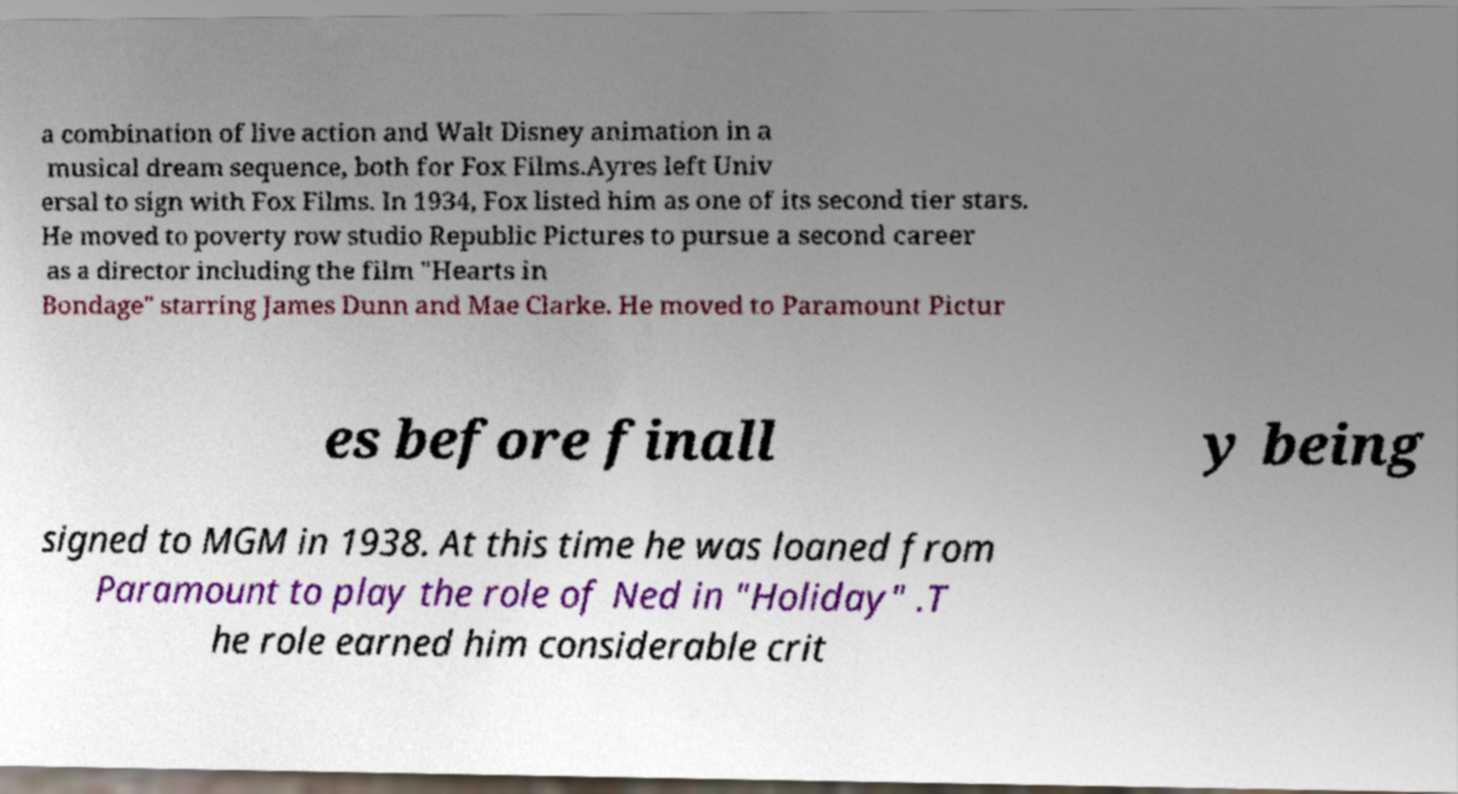For documentation purposes, I need the text within this image transcribed. Could you provide that? a combination of live action and Walt Disney animation in a musical dream sequence, both for Fox Films.Ayres left Univ ersal to sign with Fox Films. In 1934, Fox listed him as one of its second tier stars. He moved to poverty row studio Republic Pictures to pursue a second career as a director including the film "Hearts in Bondage" starring James Dunn and Mae Clarke. He moved to Paramount Pictur es before finall y being signed to MGM in 1938. At this time he was loaned from Paramount to play the role of Ned in "Holiday" .T he role earned him considerable crit 